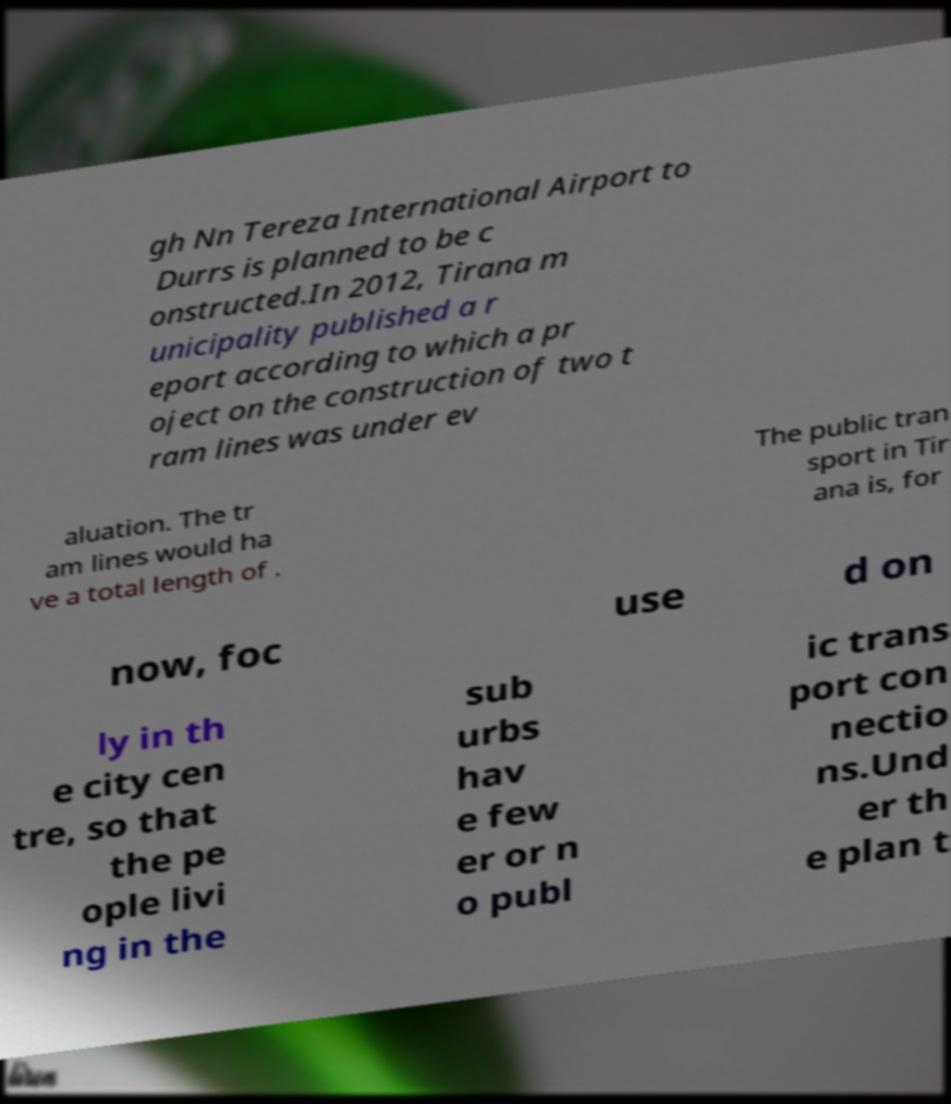For documentation purposes, I need the text within this image transcribed. Could you provide that? gh Nn Tereza International Airport to Durrs is planned to be c onstructed.In 2012, Tirana m unicipality published a r eport according to which a pr oject on the construction of two t ram lines was under ev aluation. The tr am lines would ha ve a total length of . The public tran sport in Tir ana is, for now, foc use d on ly in th e city cen tre, so that the pe ople livi ng in the sub urbs hav e few er or n o publ ic trans port con nectio ns.Und er th e plan t 